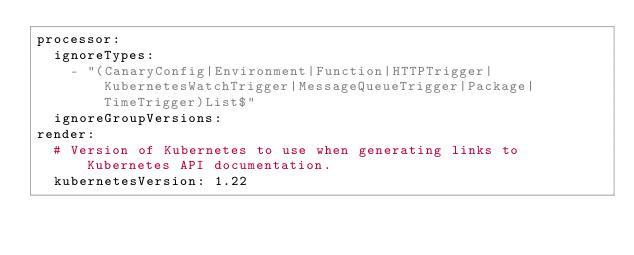<code> <loc_0><loc_0><loc_500><loc_500><_YAML_>processor:
  ignoreTypes:
    - "(CanaryConfig|Environment|Function|HTTPTrigger|KubernetesWatchTrigger|MessageQueueTrigger|Package|TimeTrigger)List$"
  ignoreGroupVersions:
render:
  # Version of Kubernetes to use when generating links to Kubernetes API documentation.
  kubernetesVersion: 1.22
</code> 